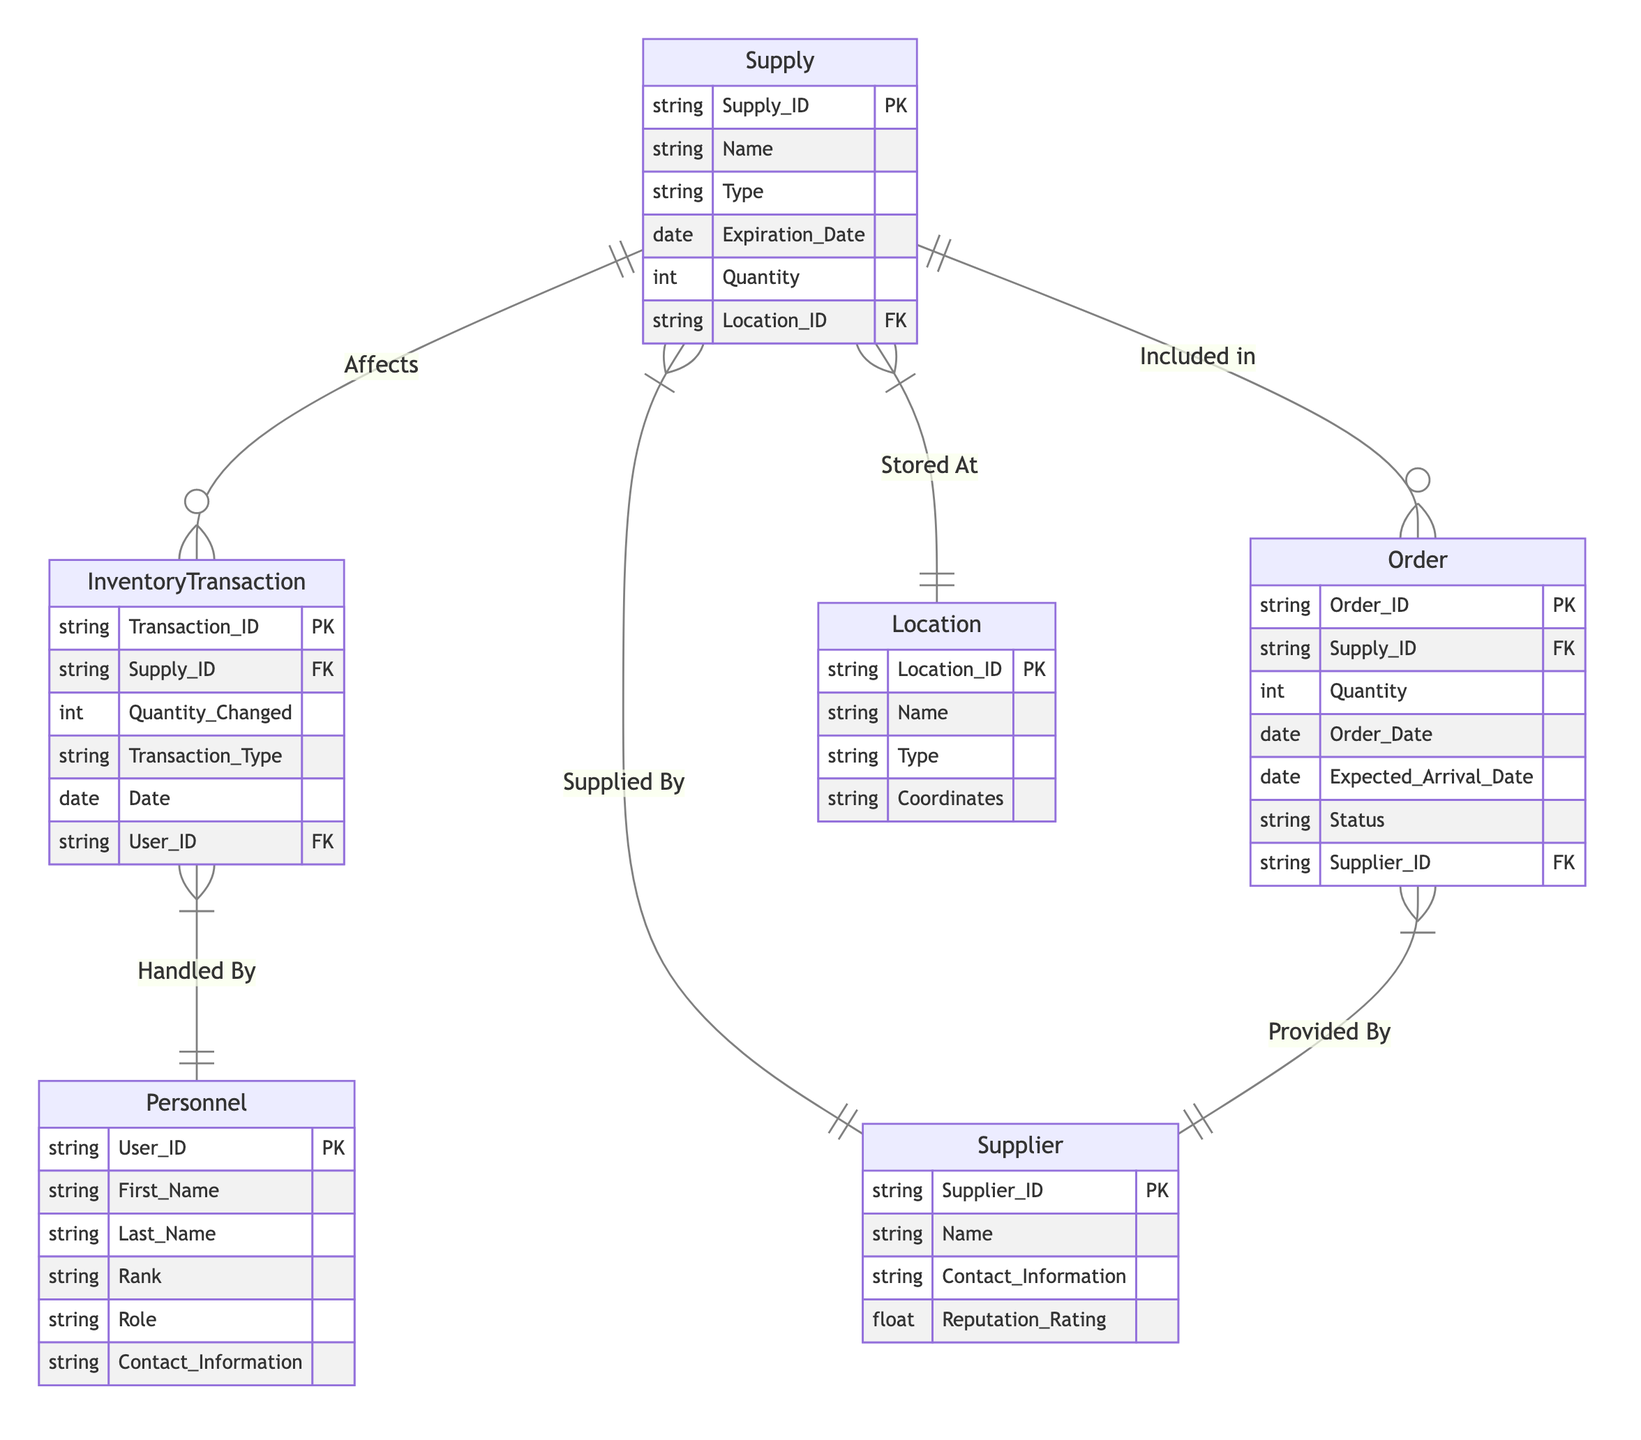What attributes does the Supply entity have? The Supply entity includes the attributes Supply_ID, Name, Type, Expiration_Date, Quantity, and Location_ID as listed in the diagram.
Answer: Supply_ID, Name, Type, Expiration_Date, Quantity, Location_ID How many entities are in the diagram? By counting the entities listed (Supply, Location, Supplier, InventoryTransaction, Personnel, and Order), there are a total of six distinct entities represented in the diagram.
Answer: 6 What is the relationship type between Order and Supplier? The relationship between Order and Supplier is defined as "Provided By," which is labeled as a many-to-one relationship in the diagram.
Answer: many-to-one Which entity is associated with the attribute "Quantity_Changed"? The attribute "Quantity_Changed" is associated with the InventoryTransaction entity, as shown in the attributes listed under that entity in the diagram.
Answer: InventoryTransaction What is the primary key of the Supplier entity? The primary key for the Supplier entity is indicated as Supplier_ID, which uniquely identifies each supplier in the database.
Answer: Supplier_ID How many transactions can a single Personnel handle? The relationship between InventoryTransaction and Personnel is many-to-one, meaning a single Personnel can handle multiple InventoryTransactions. So, the number of transactions is not limited and can be many.
Answer: many What does the "Stored At" relationship represent? The "Stored At" relationship indicates that each Supply can exist in multiple locations, while each Location can store multiple Supplies, indicating a many-to-one relationship.
Answer: Supply to Location What is the maximum number of Supplies that can be included in a single Order? The relationship between Order and Supply is many-to-one, which indicates that many Supplies can be included in one Order, meaning that an Order can contain multiple Supplies but each Supply can belong to only one Order per transaction.
Answer: many What is the significance of the Reputation Rating in the Supplier entity? The Reputation Rating attribute is likely used to assess the reliability and quality of suppliers, impacting decisions related to procurement and inventory management for combat medical supplies.
Answer: reliability and quality 